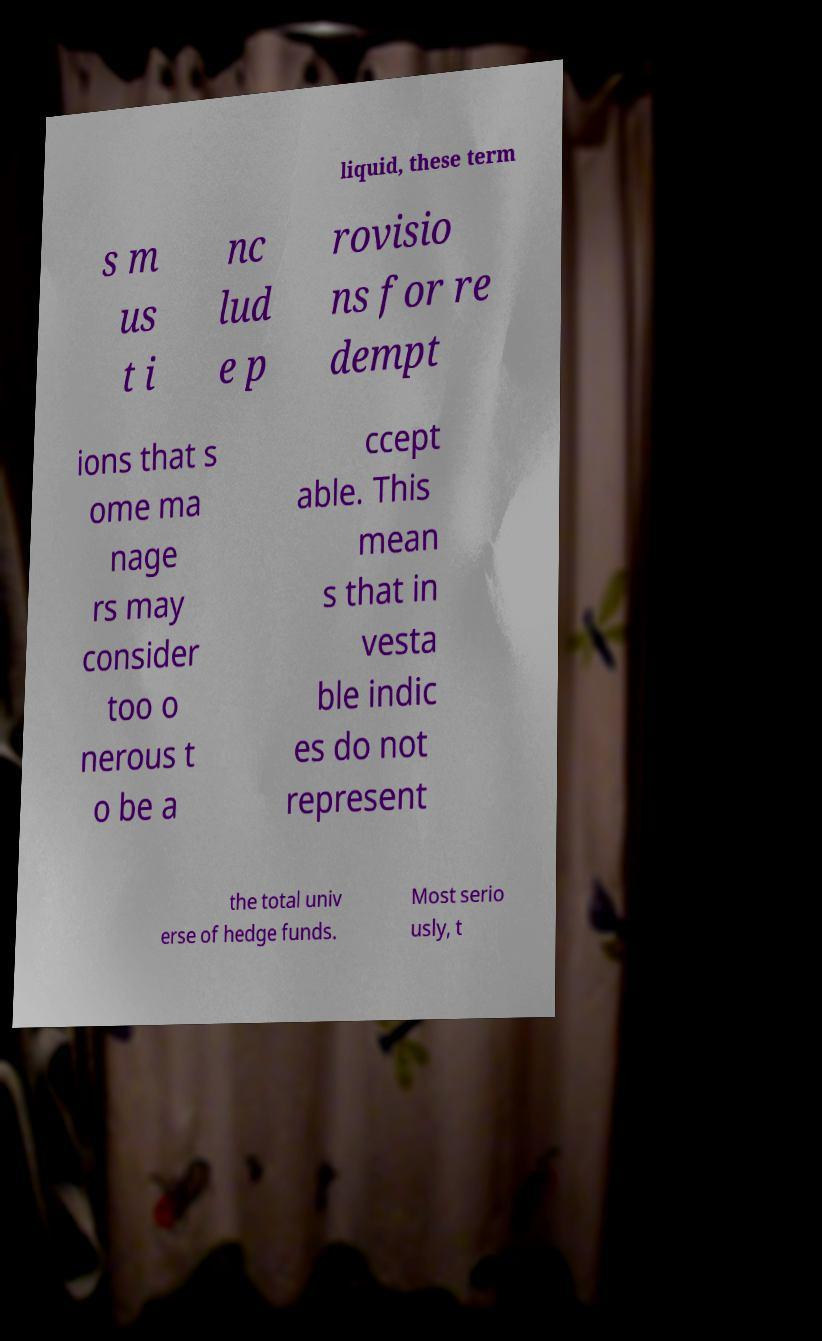Could you assist in decoding the text presented in this image and type it out clearly? liquid, these term s m us t i nc lud e p rovisio ns for re dempt ions that s ome ma nage rs may consider too o nerous t o be a ccept able. This mean s that in vesta ble indic es do not represent the total univ erse of hedge funds. Most serio usly, t 